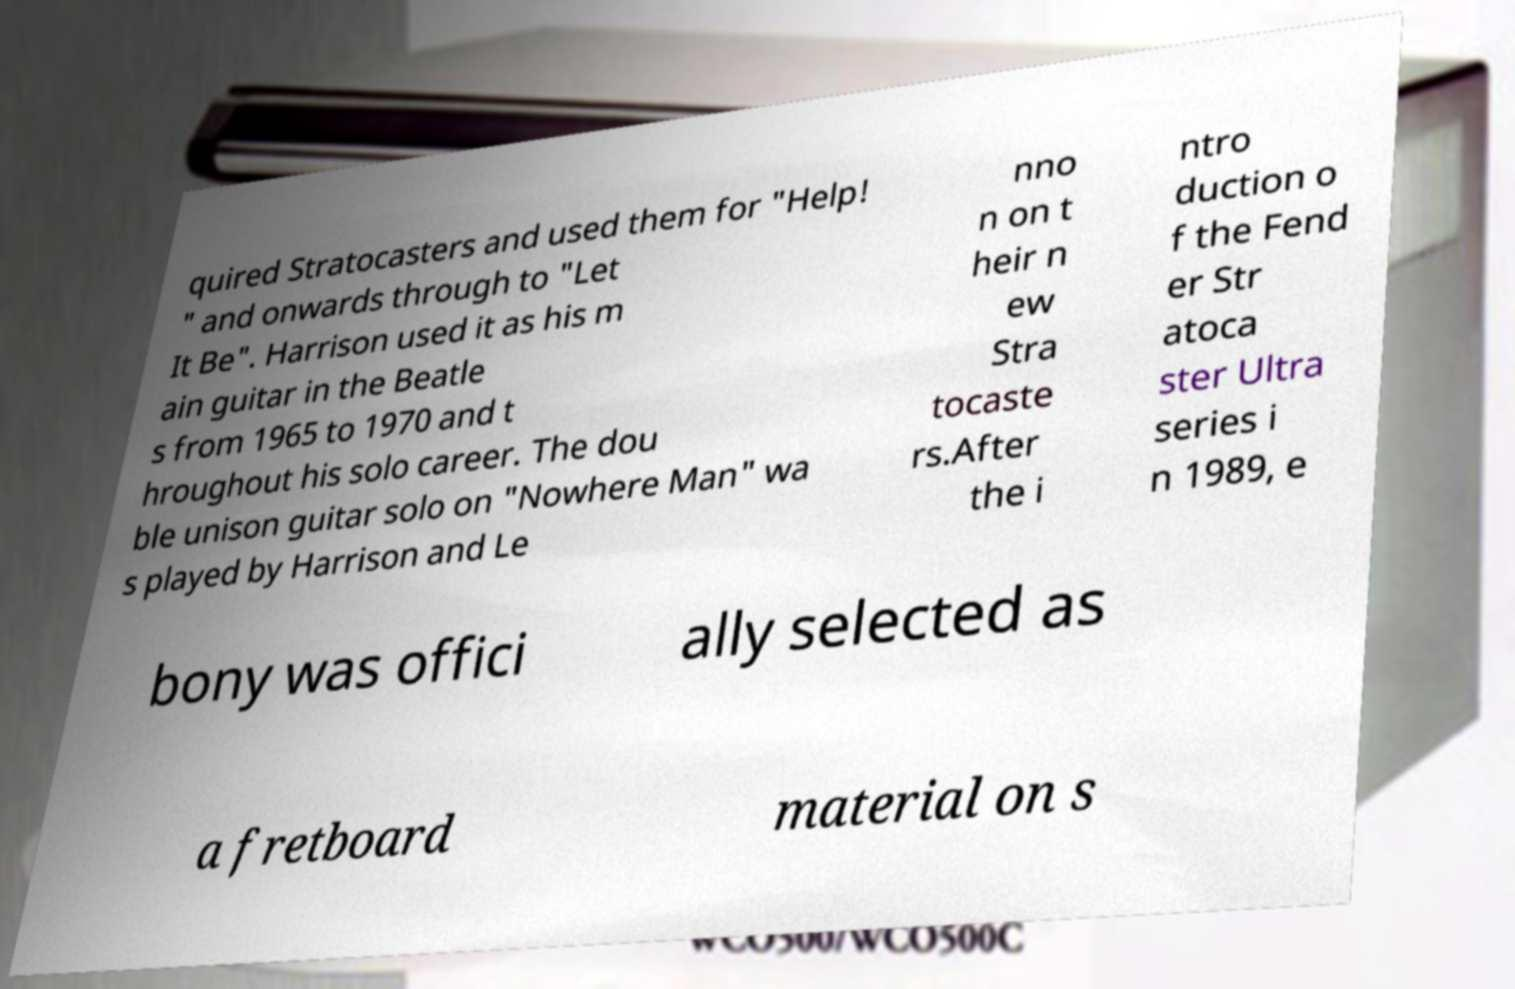Can you accurately transcribe the text from the provided image for me? quired Stratocasters and used them for "Help! " and onwards through to "Let It Be". Harrison used it as his m ain guitar in the Beatle s from 1965 to 1970 and t hroughout his solo career. The dou ble unison guitar solo on "Nowhere Man" wa s played by Harrison and Le nno n on t heir n ew Stra tocaste rs.After the i ntro duction o f the Fend er Str atoca ster Ultra series i n 1989, e bony was offici ally selected as a fretboard material on s 